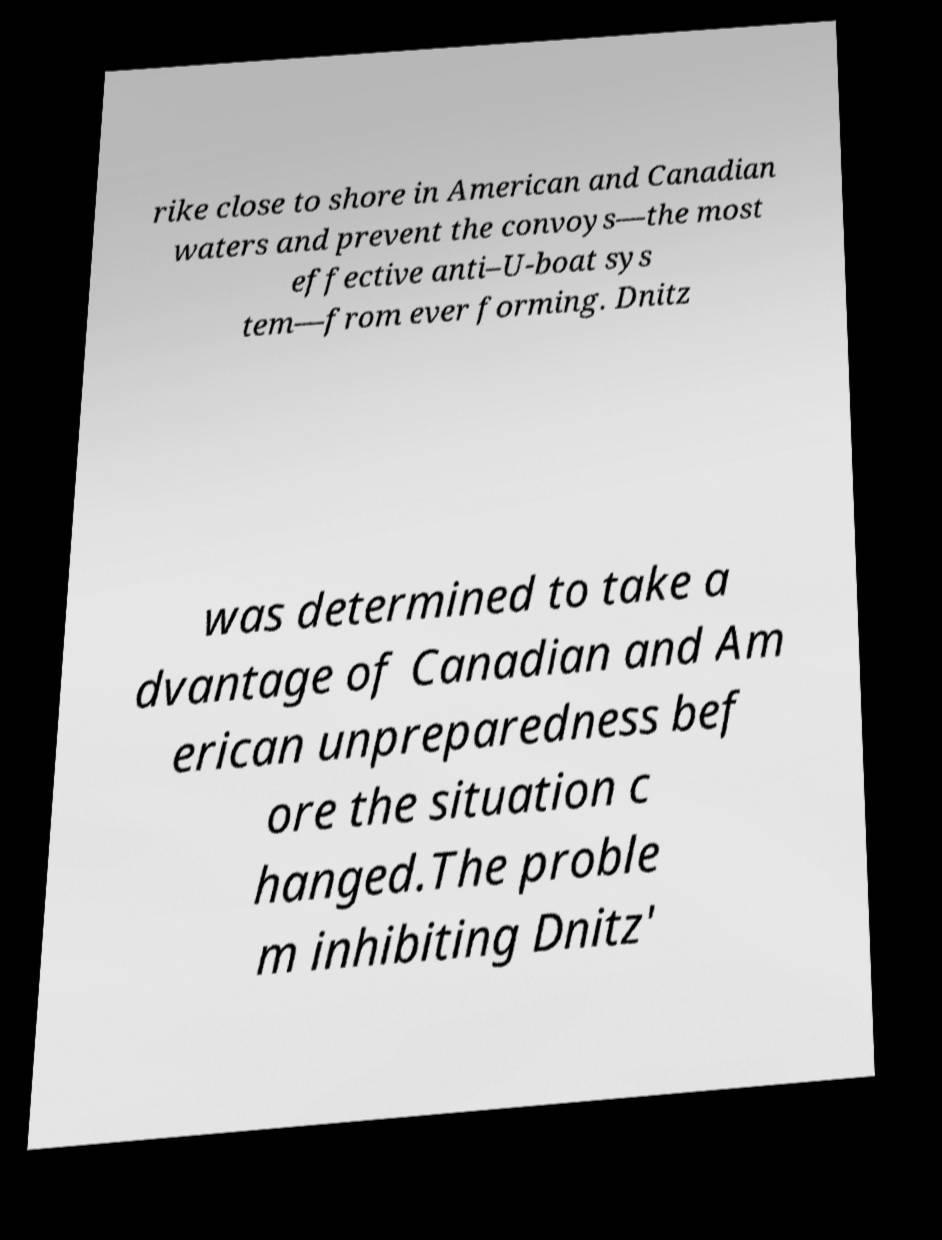Can you accurately transcribe the text from the provided image for me? rike close to shore in American and Canadian waters and prevent the convoys—the most effective anti–U-boat sys tem—from ever forming. Dnitz was determined to take a dvantage of Canadian and Am erican unpreparedness bef ore the situation c hanged.The proble m inhibiting Dnitz' 